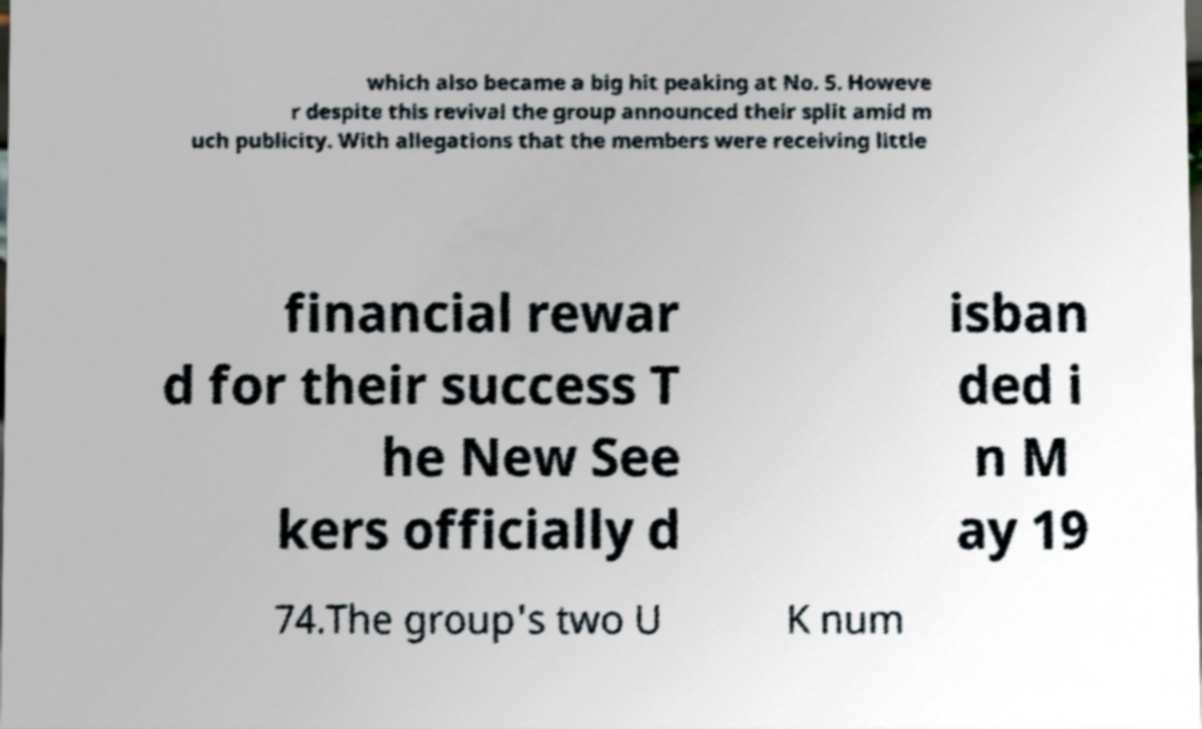Can you accurately transcribe the text from the provided image for me? which also became a big hit peaking at No. 5. Howeve r despite this revival the group announced their split amid m uch publicity. With allegations that the members were receiving little financial rewar d for their success T he New See kers officially d isban ded i n M ay 19 74.The group's two U K num 